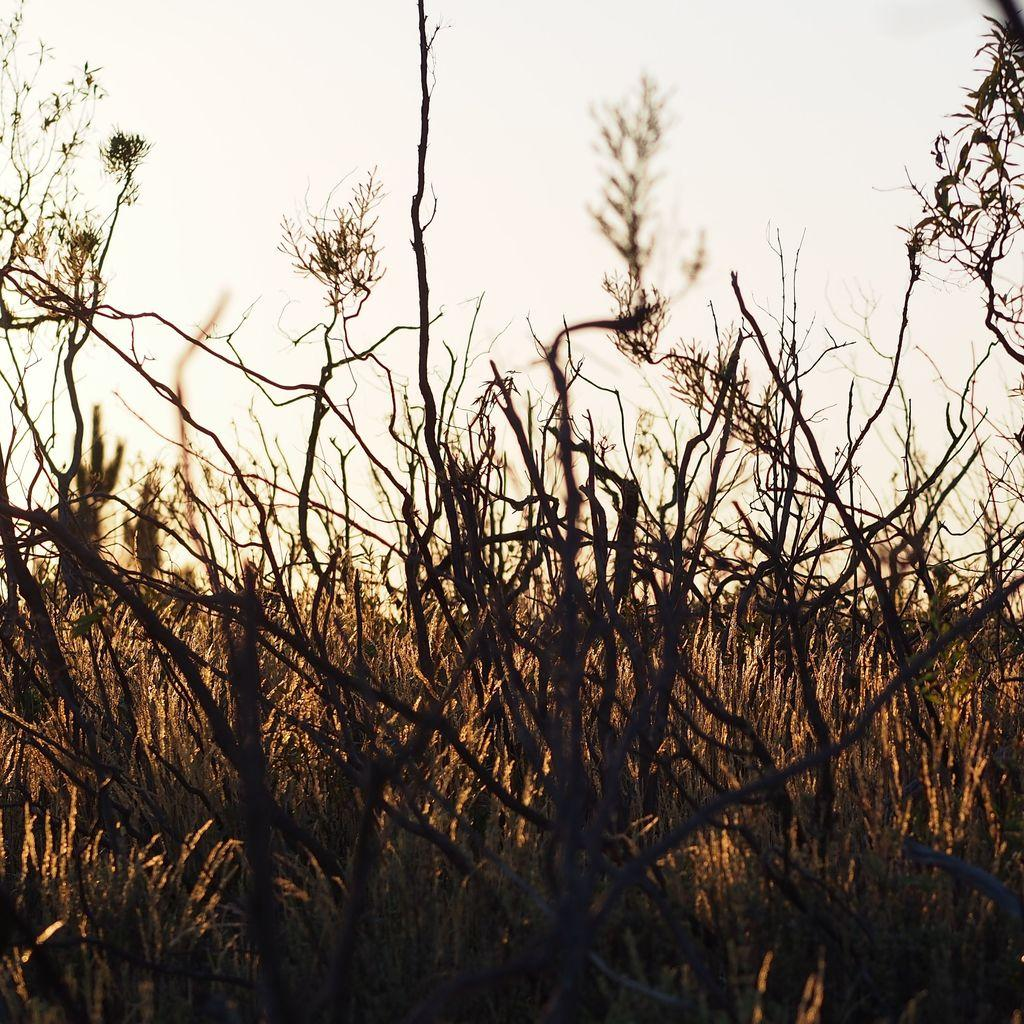Where was the image taken? The image was taken outdoors. What can be seen at the top of the image? There is a sky visible at the top of the image. What type of surface is visible in the image? There is a ground with grass in the image. What type of vegetation is present on the ground? There are plants on the ground in the image. What type of juice is being served in the basket in the image? There is no basket or juice present in the image. 